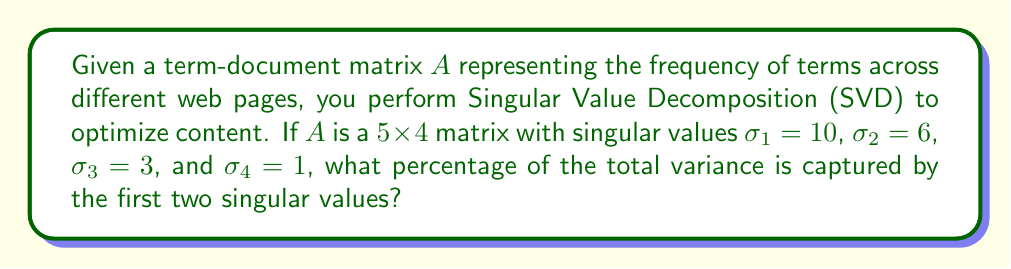Provide a solution to this math problem. To solve this problem, we'll follow these steps:

1) In SVD, the singular values represent the importance of each dimension in the data. The square of each singular value is proportional to the variance explained by that dimension.

2) The total variance is the sum of squares of all singular values:

   $$\text{Total Variance} = \sum_{i=1}^{4} \sigma_i^2 = 10^2 + 6^2 + 3^2 + 1^2 = 100 + 36 + 9 + 1 = 146$$

3) The variance captured by the first two singular values is:

   $$\text{Variance (First Two)} = \sigma_1^2 + \sigma_2^2 = 10^2 + 6^2 = 100 + 36 = 136$$

4) To calculate the percentage, we divide the variance of the first two by the total variance and multiply by 100:

   $$\text{Percentage} = \frac{\text{Variance (First Two)}}{\text{Total Variance}} \times 100\% = \frac{136}{146} \times 100\% \approx 93.15\%$$

5) Rounding to two decimal places, we get 93.15%.

This high percentage indicates that the first two dimensions (topics or concepts) capture most of the important information in the term-document matrix, which is useful for content optimization.
Answer: 93.15% 